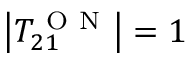<formula> <loc_0><loc_0><loc_500><loc_500>\left | T _ { 2 1 } ^ { O N } \right | = 1</formula> 